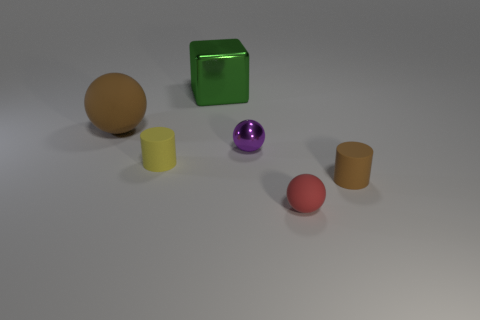Subtract all rubber spheres. How many spheres are left? 1 Subtract 1 cubes. How many cubes are left? 0 Add 1 cyan cylinders. How many objects exist? 7 Subtract all purple spheres. How many spheres are left? 2 Subtract all blocks. How many objects are left? 5 Subtract 0 purple blocks. How many objects are left? 6 Subtract all brown balls. Subtract all brown cylinders. How many balls are left? 2 Subtract all purple blocks. How many brown cylinders are left? 1 Subtract all rubber things. Subtract all cyan cubes. How many objects are left? 2 Add 3 large things. How many large things are left? 5 